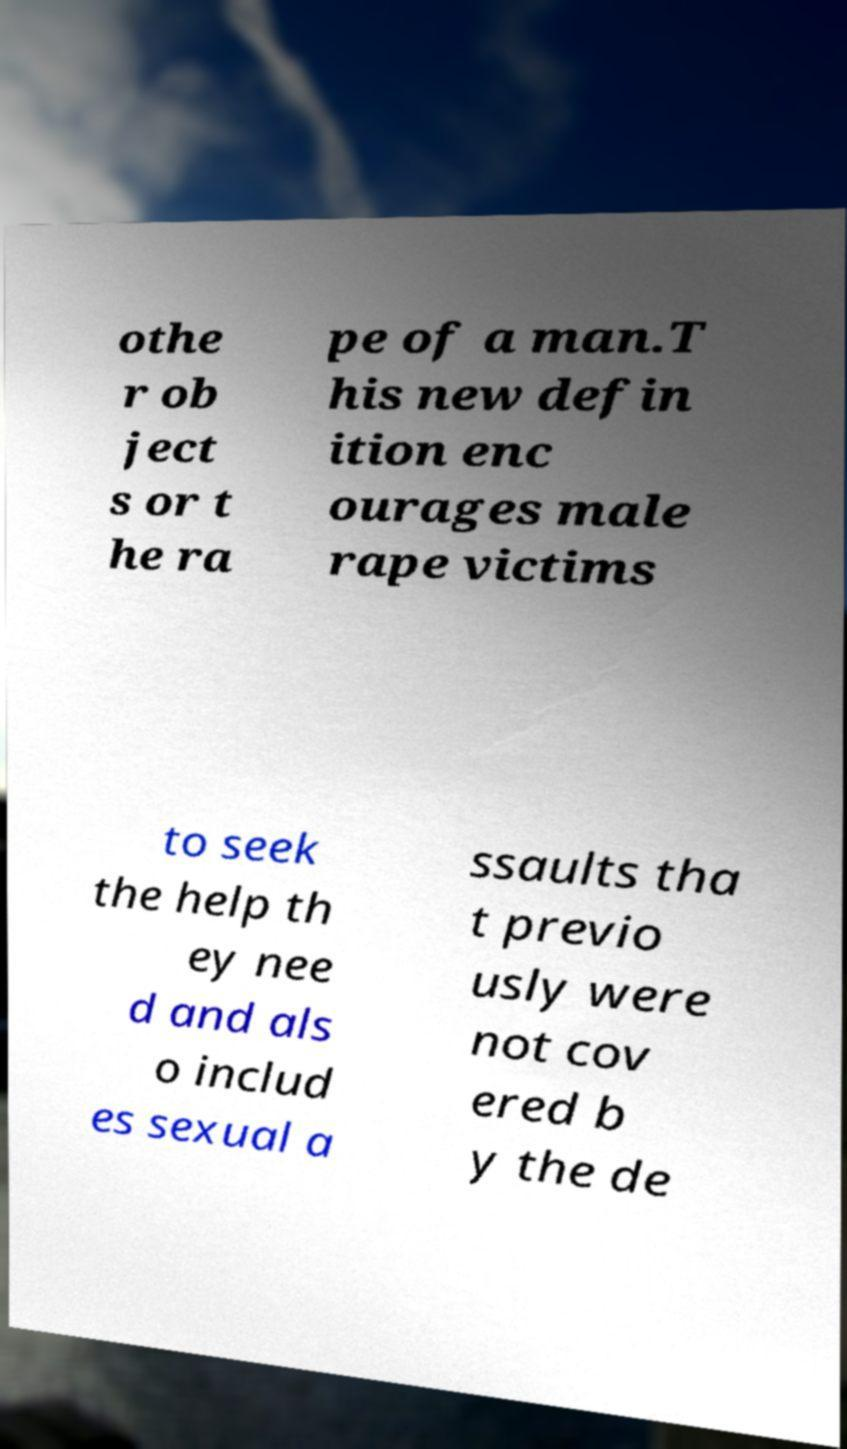There's text embedded in this image that I need extracted. Can you transcribe it verbatim? othe r ob ject s or t he ra pe of a man.T his new defin ition enc ourages male rape victims to seek the help th ey nee d and als o includ es sexual a ssaults tha t previo usly were not cov ered b y the de 